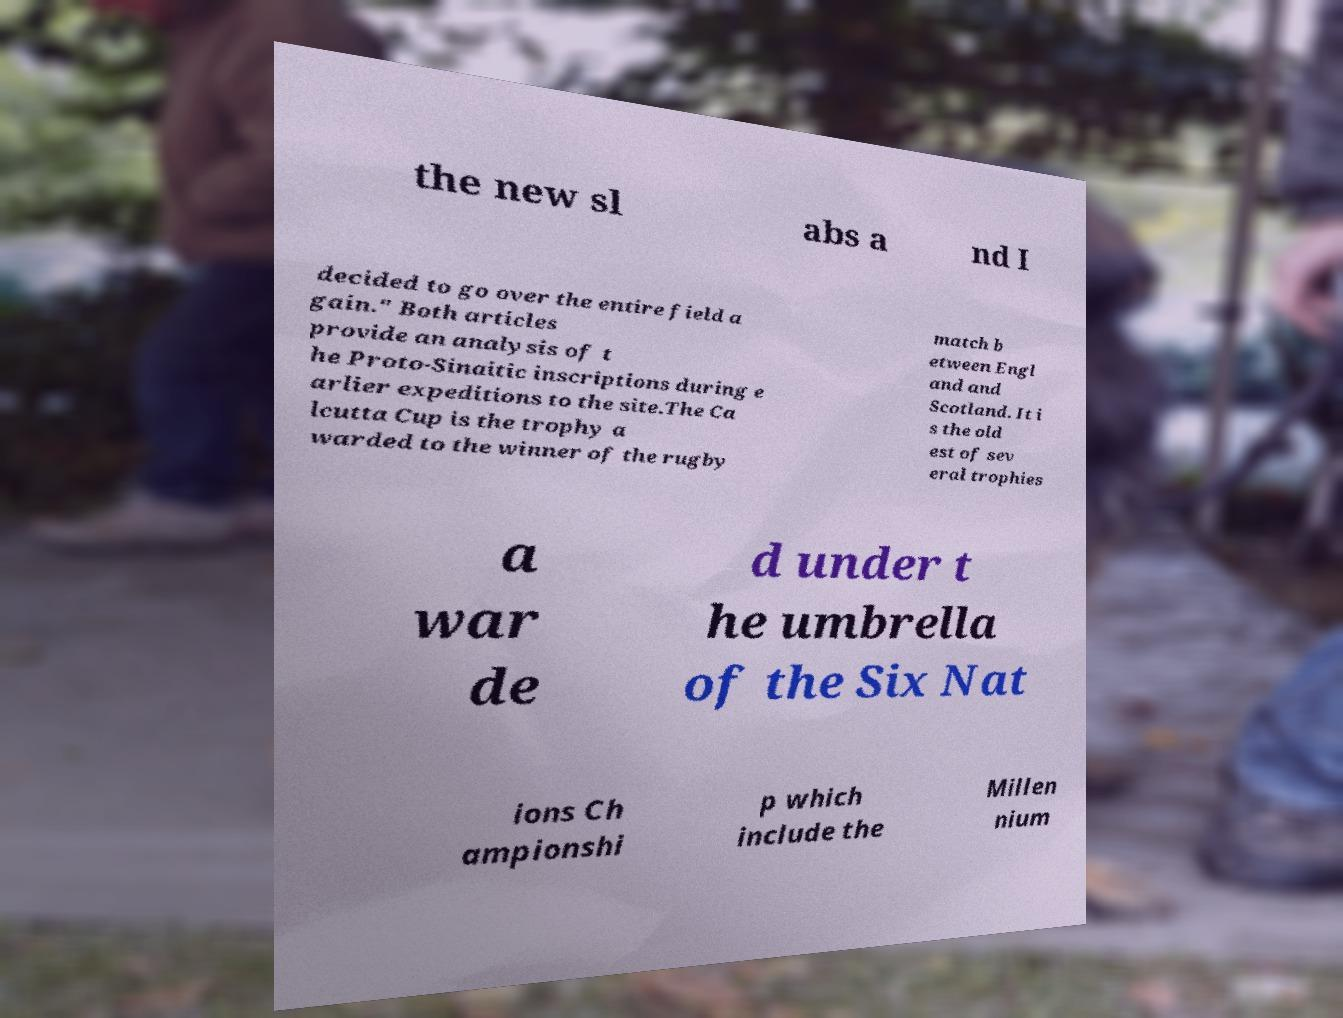Can you accurately transcribe the text from the provided image for me? the new sl abs a nd I decided to go over the entire field a gain." Both articles provide an analysis of t he Proto-Sinaitic inscriptions during e arlier expeditions to the site.The Ca lcutta Cup is the trophy a warded to the winner of the rugby match b etween Engl and and Scotland. It i s the old est of sev eral trophies a war de d under t he umbrella of the Six Nat ions Ch ampionshi p which include the Millen nium 